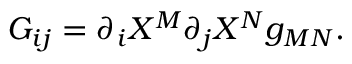Convert formula to latex. <formula><loc_0><loc_0><loc_500><loc_500>G _ { i j } = { \partial _ { i } } X ^ { M } { \partial _ { j } } X ^ { N } g _ { M N } .</formula> 